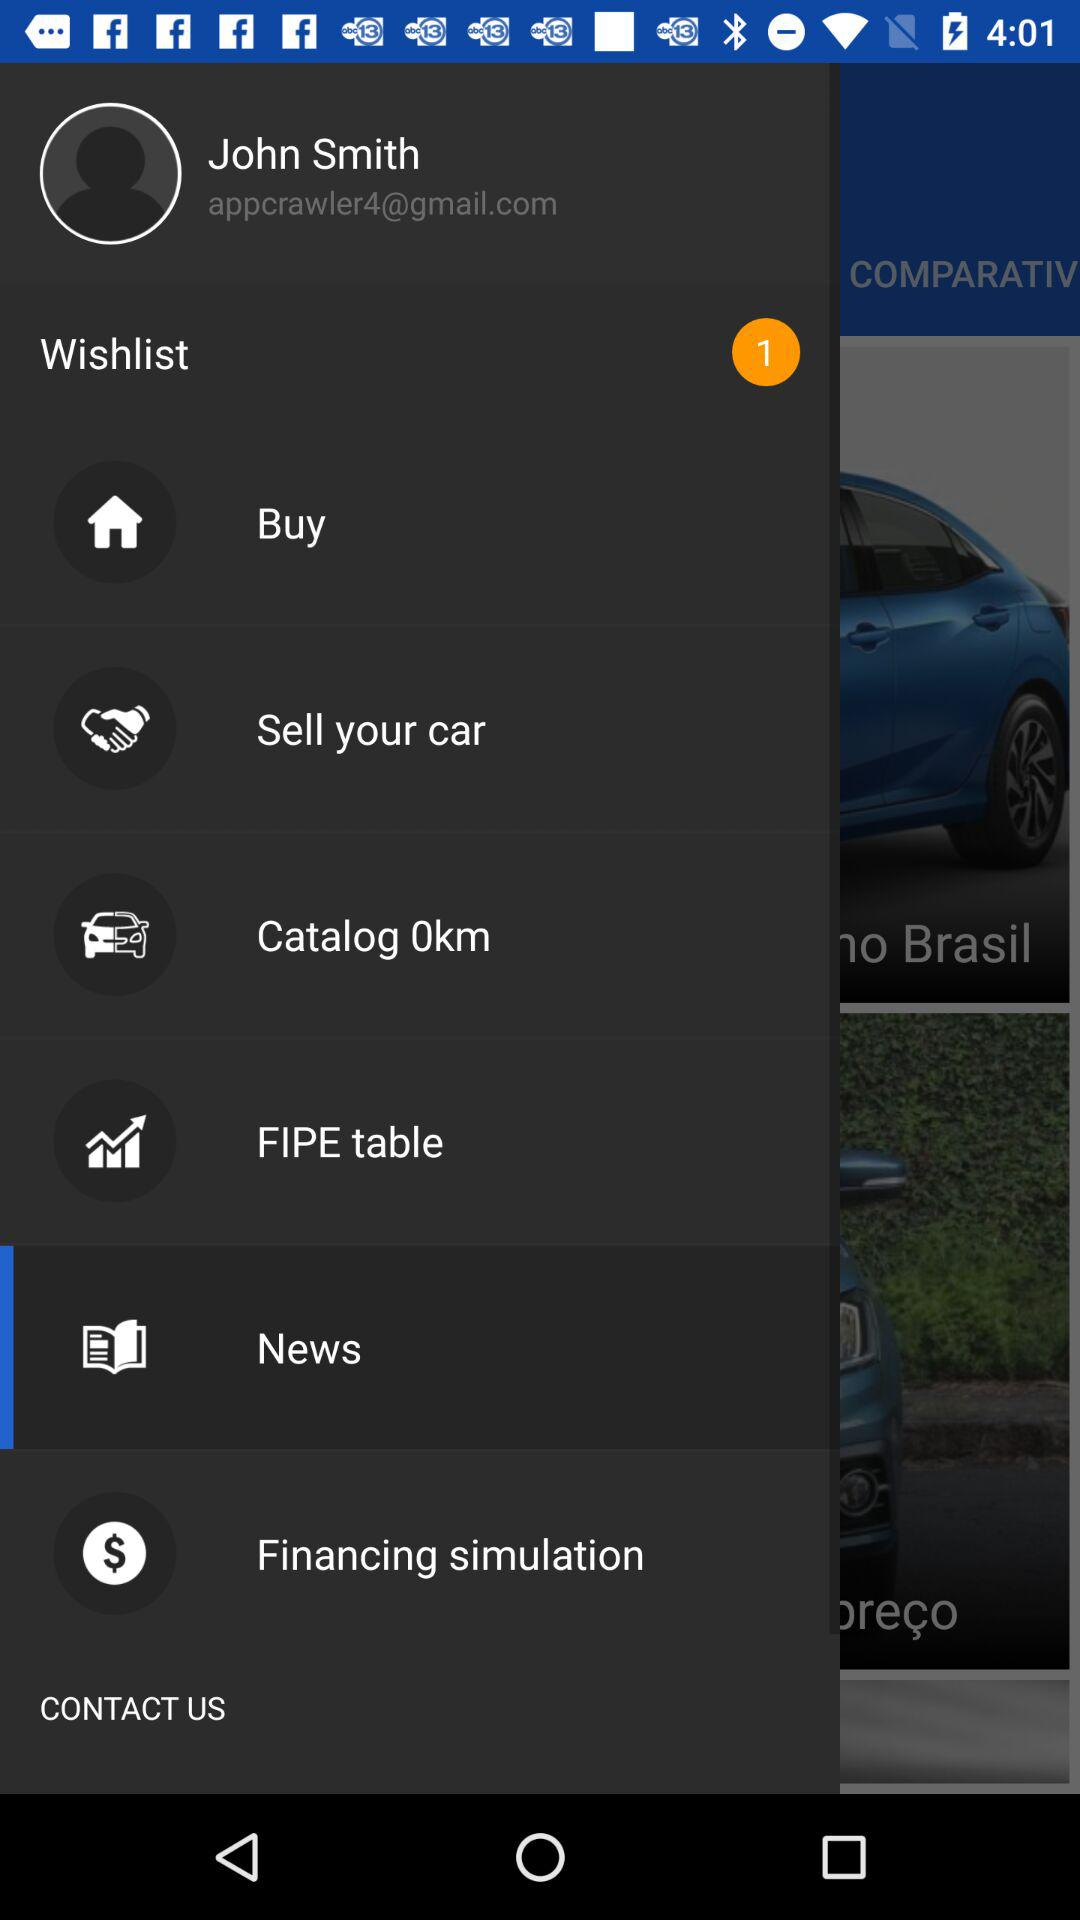What is the username? The username is John Smith. 